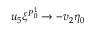<formula> <loc_0><loc_0><loc_500><loc_500>u _ { 5 } \xi ^ { P _ { 0 } ^ { 1 } } \to - v _ { 2 } \eta _ { 0 }</formula> 